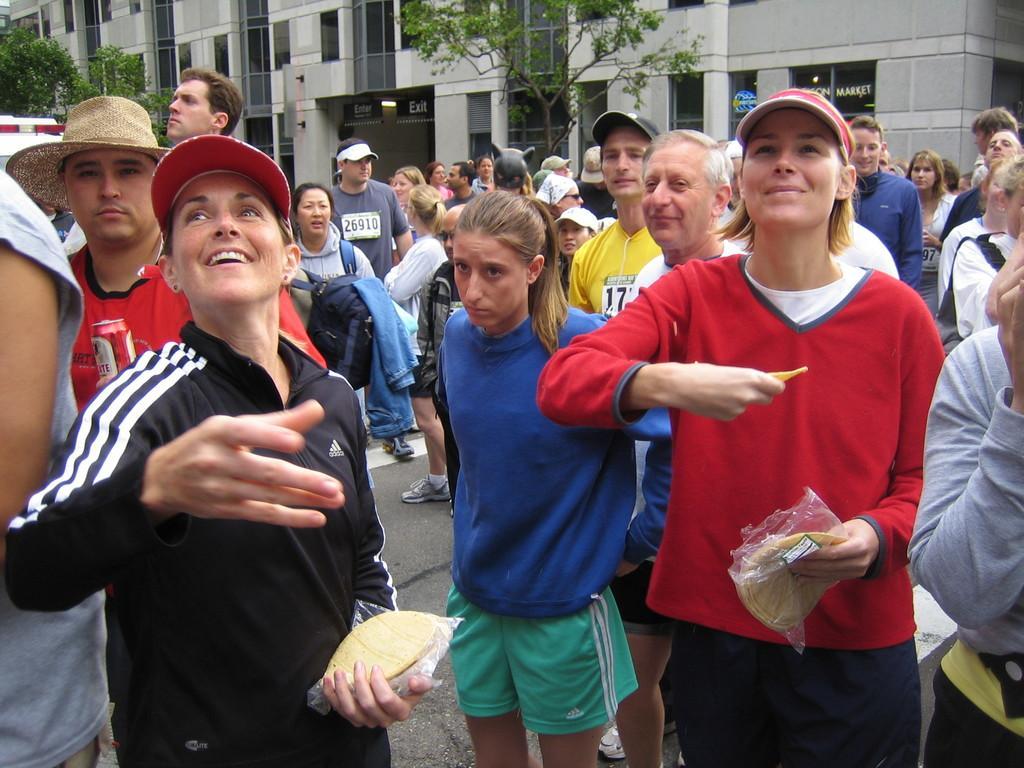Describe this image in one or two sentences. In this picture we can see a group of people standing on the road were some are smiling, caps, bag, food items, trees, name boards, buildings, vehicle and some objects. 